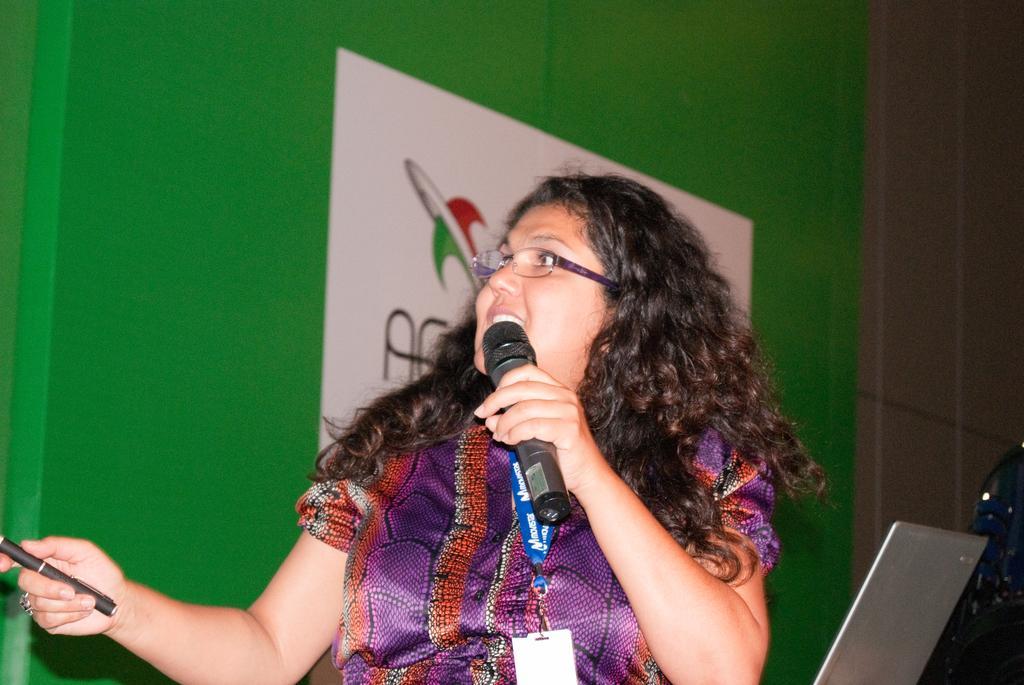Please provide a concise description of this image. In this Image I see a woman who is holding a mic and a pen in her hands, I can also see a laptop over here. 